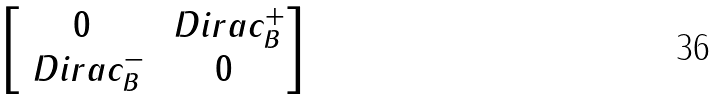Convert formula to latex. <formula><loc_0><loc_0><loc_500><loc_500>\begin{bmatrix} 0 & \ D i r a c _ { B } ^ { + } \\ \ D i r a c _ { B } ^ { - } & 0 \end{bmatrix}</formula> 